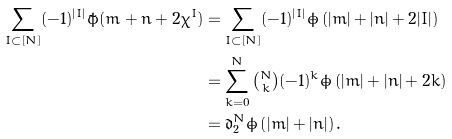Convert formula to latex. <formula><loc_0><loc_0><loc_500><loc_500>\sum _ { I \subset [ N ] } ( - 1 ) ^ { | I | } \tilde { \phi } ( m + n + 2 \chi ^ { I } ) & = \sum _ { I \subset [ N ] } ( - 1 ) ^ { | I | } \dot { \phi } \left ( | m | + | n | + 2 | I | \right ) \\ & = \sum _ { k = 0 } ^ { N } \tbinom { N } { k } ( - 1 ) ^ { k } \dot { \phi } \left ( | m | + | n | + 2 k \right ) \\ & = \mathfrak { d } _ { 2 } ^ { N } \dot { \phi } \left ( | m | + | n | \right ) .</formula> 